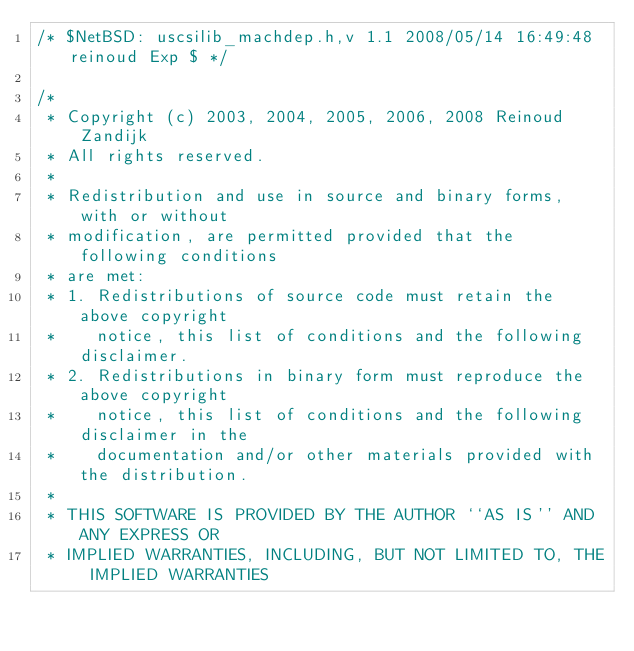Convert code to text. <code><loc_0><loc_0><loc_500><loc_500><_C_>/* $NetBSD: uscsilib_machdep.h,v 1.1 2008/05/14 16:49:48 reinoud Exp $ */

/*
 * Copyright (c) 2003, 2004, 2005, 2006, 2008 Reinoud Zandijk
 * All rights reserved.
 * 
 * Redistribution and use in source and binary forms, with or without
 * modification, are permitted provided that the following conditions
 * are met:
 * 1. Redistributions of source code must retain the above copyright
 *    notice, this list of conditions and the following disclaimer.
 * 2. Redistributions in binary form must reproduce the above copyright
 *    notice, this list of conditions and the following disclaimer in the
 *    documentation and/or other materials provided with the distribution.
 * 
 * THIS SOFTWARE IS PROVIDED BY THE AUTHOR ``AS IS'' AND ANY EXPRESS OR
 * IMPLIED WARRANTIES, INCLUDING, BUT NOT LIMITED TO, THE IMPLIED WARRANTIES</code> 